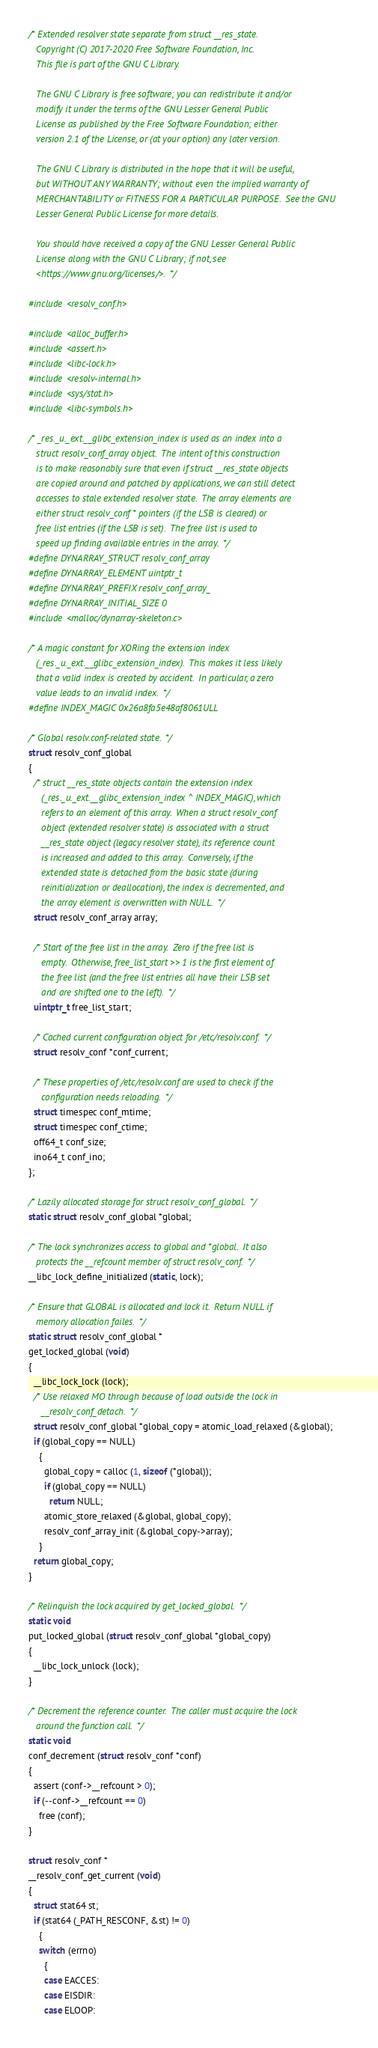<code> <loc_0><loc_0><loc_500><loc_500><_C_>/* Extended resolver state separate from struct __res_state.
   Copyright (C) 2017-2020 Free Software Foundation, Inc.
   This file is part of the GNU C Library.

   The GNU C Library is free software; you can redistribute it and/or
   modify it under the terms of the GNU Lesser General Public
   License as published by the Free Software Foundation; either
   version 2.1 of the License, or (at your option) any later version.

   The GNU C Library is distributed in the hope that it will be useful,
   but WITHOUT ANY WARRANTY; without even the implied warranty of
   MERCHANTABILITY or FITNESS FOR A PARTICULAR PURPOSE.  See the GNU
   Lesser General Public License for more details.

   You should have received a copy of the GNU Lesser General Public
   License along with the GNU C Library; if not, see
   <https://www.gnu.org/licenses/>.  */

#include <resolv_conf.h>

#include <alloc_buffer.h>
#include <assert.h>
#include <libc-lock.h>
#include <resolv-internal.h>
#include <sys/stat.h>
#include <libc-symbols.h>

/* _res._u._ext.__glibc_extension_index is used as an index into a
   struct resolv_conf_array object.  The intent of this construction
   is to make reasonably sure that even if struct __res_state objects
   are copied around and patched by applications, we can still detect
   accesses to stale extended resolver state.  The array elements are
   either struct resolv_conf * pointers (if the LSB is cleared) or
   free list entries (if the LSB is set).  The free list is used to
   speed up finding available entries in the array.  */
#define DYNARRAY_STRUCT resolv_conf_array
#define DYNARRAY_ELEMENT uintptr_t
#define DYNARRAY_PREFIX resolv_conf_array_
#define DYNARRAY_INITIAL_SIZE 0
#include <malloc/dynarray-skeleton.c>

/* A magic constant for XORing the extension index
   (_res._u._ext.__glibc_extension_index).  This makes it less likely
   that a valid index is created by accident.  In particular, a zero
   value leads to an invalid index.  */
#define INDEX_MAGIC 0x26a8fa5e48af8061ULL

/* Global resolv.conf-related state.  */
struct resolv_conf_global
{
  /* struct __res_state objects contain the extension index
     (_res._u._ext.__glibc_extension_index ^ INDEX_MAGIC), which
     refers to an element of this array.  When a struct resolv_conf
     object (extended resolver state) is associated with a struct
     __res_state object (legacy resolver state), its reference count
     is increased and added to this array.  Conversely, if the
     extended state is detached from the basic state (during
     reinitialization or deallocation), the index is decremented, and
     the array element is overwritten with NULL.  */
  struct resolv_conf_array array;

  /* Start of the free list in the array.  Zero if the free list is
     empty.  Otherwise, free_list_start >> 1 is the first element of
     the free list (and the free list entries all have their LSB set
     and are shifted one to the left).  */
  uintptr_t free_list_start;

  /* Cached current configuration object for /etc/resolv.conf.  */
  struct resolv_conf *conf_current;

  /* These properties of /etc/resolv.conf are used to check if the
     configuration needs reloading.  */
  struct timespec conf_mtime;
  struct timespec conf_ctime;
  off64_t conf_size;
  ino64_t conf_ino;
};

/* Lazily allocated storage for struct resolv_conf_global.  */
static struct resolv_conf_global *global;

/* The lock synchronizes access to global and *global.  It also
   protects the __refcount member of struct resolv_conf.  */
__libc_lock_define_initialized (static, lock);

/* Ensure that GLOBAL is allocated and lock it.  Return NULL if
   memory allocation failes.  */
static struct resolv_conf_global *
get_locked_global (void)
{
  __libc_lock_lock (lock);
  /* Use relaxed MO through because of load outside the lock in
     __resolv_conf_detach.  */
  struct resolv_conf_global *global_copy = atomic_load_relaxed (&global);
  if (global_copy == NULL)
    {
      global_copy = calloc (1, sizeof (*global));
      if (global_copy == NULL)
        return NULL;
      atomic_store_relaxed (&global, global_copy);
      resolv_conf_array_init (&global_copy->array);
    }
  return global_copy;
}

/* Relinquish the lock acquired by get_locked_global.  */
static void
put_locked_global (struct resolv_conf_global *global_copy)
{
  __libc_lock_unlock (lock);
}

/* Decrement the reference counter.  The caller must acquire the lock
   around the function call.  */
static void
conf_decrement (struct resolv_conf *conf)
{
  assert (conf->__refcount > 0);
  if (--conf->__refcount == 0)
    free (conf);
}

struct resolv_conf *
__resolv_conf_get_current (void)
{
  struct stat64 st;
  if (stat64 (_PATH_RESCONF, &st) != 0)
    {
    switch (errno)
      {
      case EACCES:
      case EISDIR:
      case ELOOP:</code> 